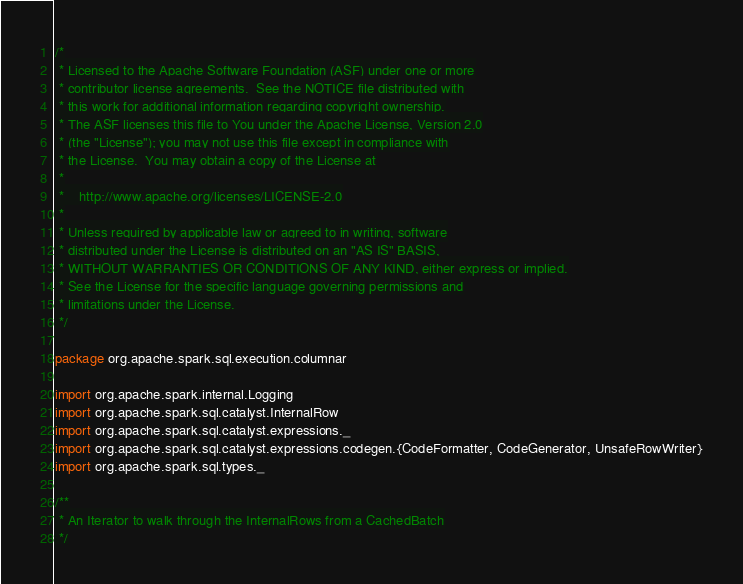<code> <loc_0><loc_0><loc_500><loc_500><_Scala_>/*
 * Licensed to the Apache Software Foundation (ASF) under one or more
 * contributor license agreements.  See the NOTICE file distributed with
 * this work for additional information regarding copyright ownership.
 * The ASF licenses this file to You under the Apache License, Version 2.0
 * (the "License"); you may not use this file except in compliance with
 * the License.  You may obtain a copy of the License at
 *
 *    http://www.apache.org/licenses/LICENSE-2.0
 *
 * Unless required by applicable law or agreed to in writing, software
 * distributed under the License is distributed on an "AS IS" BASIS,
 * WITHOUT WARRANTIES OR CONDITIONS OF ANY KIND, either express or implied.
 * See the License for the specific language governing permissions and
 * limitations under the License.
 */

package org.apache.spark.sql.execution.columnar

import org.apache.spark.internal.Logging
import org.apache.spark.sql.catalyst.InternalRow
import org.apache.spark.sql.catalyst.expressions._
import org.apache.spark.sql.catalyst.expressions.codegen.{CodeFormatter, CodeGenerator, UnsafeRowWriter}
import org.apache.spark.sql.types._

/**
 * An Iterator to walk through the InternalRows from a CachedBatch
 */</code> 